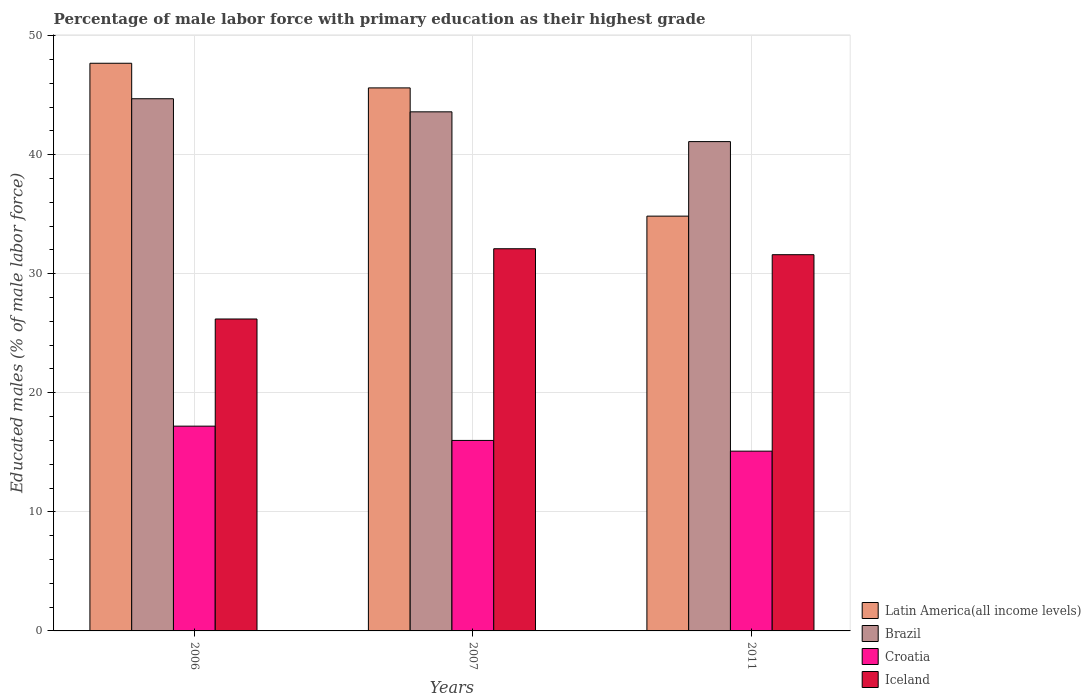How many groups of bars are there?
Keep it short and to the point. 3. Are the number of bars on each tick of the X-axis equal?
Your response must be concise. Yes. How many bars are there on the 3rd tick from the left?
Offer a terse response. 4. What is the percentage of male labor force with primary education in Croatia in 2006?
Provide a short and direct response. 17.2. Across all years, what is the maximum percentage of male labor force with primary education in Iceland?
Your answer should be compact. 32.1. Across all years, what is the minimum percentage of male labor force with primary education in Iceland?
Your answer should be compact. 26.2. In which year was the percentage of male labor force with primary education in Croatia minimum?
Ensure brevity in your answer.  2011. What is the total percentage of male labor force with primary education in Latin America(all income levels) in the graph?
Provide a succinct answer. 128.13. What is the difference between the percentage of male labor force with primary education in Croatia in 2006 and that in 2011?
Give a very brief answer. 2.1. What is the difference between the percentage of male labor force with primary education in Iceland in 2007 and the percentage of male labor force with primary education in Croatia in 2006?
Your response must be concise. 14.9. What is the average percentage of male labor force with primary education in Brazil per year?
Offer a very short reply. 43.13. In the year 2006, what is the difference between the percentage of male labor force with primary education in Iceland and percentage of male labor force with primary education in Brazil?
Keep it short and to the point. -18.5. In how many years, is the percentage of male labor force with primary education in Brazil greater than 38 %?
Your answer should be compact. 3. What is the ratio of the percentage of male labor force with primary education in Brazil in 2006 to that in 2011?
Provide a short and direct response. 1.09. Is the percentage of male labor force with primary education in Brazil in 2006 less than that in 2007?
Keep it short and to the point. No. What is the difference between the highest and the second highest percentage of male labor force with primary education in Latin America(all income levels)?
Ensure brevity in your answer.  2.07. What is the difference between the highest and the lowest percentage of male labor force with primary education in Brazil?
Offer a very short reply. 3.6. In how many years, is the percentage of male labor force with primary education in Iceland greater than the average percentage of male labor force with primary education in Iceland taken over all years?
Offer a terse response. 2. Is it the case that in every year, the sum of the percentage of male labor force with primary education in Brazil and percentage of male labor force with primary education in Iceland is greater than the sum of percentage of male labor force with primary education in Croatia and percentage of male labor force with primary education in Latin America(all income levels)?
Provide a succinct answer. No. What does the 4th bar from the right in 2011 represents?
Give a very brief answer. Latin America(all income levels). Is it the case that in every year, the sum of the percentage of male labor force with primary education in Latin America(all income levels) and percentage of male labor force with primary education in Croatia is greater than the percentage of male labor force with primary education in Brazil?
Your response must be concise. Yes. How many bars are there?
Make the answer very short. 12. What is the difference between two consecutive major ticks on the Y-axis?
Your response must be concise. 10. Are the values on the major ticks of Y-axis written in scientific E-notation?
Make the answer very short. No. Does the graph contain grids?
Your answer should be very brief. Yes. How many legend labels are there?
Your answer should be very brief. 4. What is the title of the graph?
Your answer should be compact. Percentage of male labor force with primary education as their highest grade. Does "Poland" appear as one of the legend labels in the graph?
Your answer should be compact. No. What is the label or title of the Y-axis?
Give a very brief answer. Educated males (% of male labor force). What is the Educated males (% of male labor force) of Latin America(all income levels) in 2006?
Make the answer very short. 47.68. What is the Educated males (% of male labor force) of Brazil in 2006?
Provide a succinct answer. 44.7. What is the Educated males (% of male labor force) of Croatia in 2006?
Keep it short and to the point. 17.2. What is the Educated males (% of male labor force) in Iceland in 2006?
Your answer should be very brief. 26.2. What is the Educated males (% of male labor force) of Latin America(all income levels) in 2007?
Your answer should be very brief. 45.61. What is the Educated males (% of male labor force) of Brazil in 2007?
Offer a very short reply. 43.6. What is the Educated males (% of male labor force) of Iceland in 2007?
Keep it short and to the point. 32.1. What is the Educated males (% of male labor force) in Latin America(all income levels) in 2011?
Ensure brevity in your answer.  34.84. What is the Educated males (% of male labor force) of Brazil in 2011?
Your response must be concise. 41.1. What is the Educated males (% of male labor force) of Croatia in 2011?
Provide a short and direct response. 15.1. What is the Educated males (% of male labor force) in Iceland in 2011?
Your response must be concise. 31.6. Across all years, what is the maximum Educated males (% of male labor force) of Latin America(all income levels)?
Provide a succinct answer. 47.68. Across all years, what is the maximum Educated males (% of male labor force) of Brazil?
Ensure brevity in your answer.  44.7. Across all years, what is the maximum Educated males (% of male labor force) in Croatia?
Your answer should be compact. 17.2. Across all years, what is the maximum Educated males (% of male labor force) of Iceland?
Give a very brief answer. 32.1. Across all years, what is the minimum Educated males (% of male labor force) of Latin America(all income levels)?
Provide a short and direct response. 34.84. Across all years, what is the minimum Educated males (% of male labor force) of Brazil?
Your answer should be very brief. 41.1. Across all years, what is the minimum Educated males (% of male labor force) in Croatia?
Provide a succinct answer. 15.1. Across all years, what is the minimum Educated males (% of male labor force) of Iceland?
Ensure brevity in your answer.  26.2. What is the total Educated males (% of male labor force) of Latin America(all income levels) in the graph?
Ensure brevity in your answer.  128.13. What is the total Educated males (% of male labor force) in Brazil in the graph?
Provide a short and direct response. 129.4. What is the total Educated males (% of male labor force) in Croatia in the graph?
Offer a very short reply. 48.3. What is the total Educated males (% of male labor force) in Iceland in the graph?
Provide a succinct answer. 89.9. What is the difference between the Educated males (% of male labor force) in Latin America(all income levels) in 2006 and that in 2007?
Give a very brief answer. 2.07. What is the difference between the Educated males (% of male labor force) in Brazil in 2006 and that in 2007?
Offer a terse response. 1.1. What is the difference between the Educated males (% of male labor force) in Croatia in 2006 and that in 2007?
Make the answer very short. 1.2. What is the difference between the Educated males (% of male labor force) of Iceland in 2006 and that in 2007?
Give a very brief answer. -5.9. What is the difference between the Educated males (% of male labor force) in Latin America(all income levels) in 2006 and that in 2011?
Your response must be concise. 12.84. What is the difference between the Educated males (% of male labor force) in Latin America(all income levels) in 2007 and that in 2011?
Provide a short and direct response. 10.77. What is the difference between the Educated males (% of male labor force) of Latin America(all income levels) in 2006 and the Educated males (% of male labor force) of Brazil in 2007?
Offer a very short reply. 4.08. What is the difference between the Educated males (% of male labor force) of Latin America(all income levels) in 2006 and the Educated males (% of male labor force) of Croatia in 2007?
Make the answer very short. 31.68. What is the difference between the Educated males (% of male labor force) in Latin America(all income levels) in 2006 and the Educated males (% of male labor force) in Iceland in 2007?
Your answer should be very brief. 15.58. What is the difference between the Educated males (% of male labor force) in Brazil in 2006 and the Educated males (% of male labor force) in Croatia in 2007?
Make the answer very short. 28.7. What is the difference between the Educated males (% of male labor force) in Croatia in 2006 and the Educated males (% of male labor force) in Iceland in 2007?
Your answer should be compact. -14.9. What is the difference between the Educated males (% of male labor force) of Latin America(all income levels) in 2006 and the Educated males (% of male labor force) of Brazil in 2011?
Your answer should be very brief. 6.58. What is the difference between the Educated males (% of male labor force) of Latin America(all income levels) in 2006 and the Educated males (% of male labor force) of Croatia in 2011?
Ensure brevity in your answer.  32.58. What is the difference between the Educated males (% of male labor force) of Latin America(all income levels) in 2006 and the Educated males (% of male labor force) of Iceland in 2011?
Your answer should be very brief. 16.08. What is the difference between the Educated males (% of male labor force) in Brazil in 2006 and the Educated males (% of male labor force) in Croatia in 2011?
Make the answer very short. 29.6. What is the difference between the Educated males (% of male labor force) of Brazil in 2006 and the Educated males (% of male labor force) of Iceland in 2011?
Provide a succinct answer. 13.1. What is the difference between the Educated males (% of male labor force) of Croatia in 2006 and the Educated males (% of male labor force) of Iceland in 2011?
Ensure brevity in your answer.  -14.4. What is the difference between the Educated males (% of male labor force) in Latin America(all income levels) in 2007 and the Educated males (% of male labor force) in Brazil in 2011?
Keep it short and to the point. 4.51. What is the difference between the Educated males (% of male labor force) of Latin America(all income levels) in 2007 and the Educated males (% of male labor force) of Croatia in 2011?
Make the answer very short. 30.51. What is the difference between the Educated males (% of male labor force) of Latin America(all income levels) in 2007 and the Educated males (% of male labor force) of Iceland in 2011?
Offer a terse response. 14.01. What is the difference between the Educated males (% of male labor force) of Brazil in 2007 and the Educated males (% of male labor force) of Croatia in 2011?
Provide a succinct answer. 28.5. What is the difference between the Educated males (% of male labor force) in Brazil in 2007 and the Educated males (% of male labor force) in Iceland in 2011?
Keep it short and to the point. 12. What is the difference between the Educated males (% of male labor force) of Croatia in 2007 and the Educated males (% of male labor force) of Iceland in 2011?
Provide a succinct answer. -15.6. What is the average Educated males (% of male labor force) in Latin America(all income levels) per year?
Your response must be concise. 42.71. What is the average Educated males (% of male labor force) of Brazil per year?
Your answer should be compact. 43.13. What is the average Educated males (% of male labor force) in Iceland per year?
Offer a terse response. 29.97. In the year 2006, what is the difference between the Educated males (% of male labor force) in Latin America(all income levels) and Educated males (% of male labor force) in Brazil?
Your answer should be compact. 2.98. In the year 2006, what is the difference between the Educated males (% of male labor force) in Latin America(all income levels) and Educated males (% of male labor force) in Croatia?
Your answer should be very brief. 30.48. In the year 2006, what is the difference between the Educated males (% of male labor force) in Latin America(all income levels) and Educated males (% of male labor force) in Iceland?
Make the answer very short. 21.48. In the year 2006, what is the difference between the Educated males (% of male labor force) in Brazil and Educated males (% of male labor force) in Croatia?
Keep it short and to the point. 27.5. In the year 2006, what is the difference between the Educated males (% of male labor force) in Brazil and Educated males (% of male labor force) in Iceland?
Keep it short and to the point. 18.5. In the year 2006, what is the difference between the Educated males (% of male labor force) in Croatia and Educated males (% of male labor force) in Iceland?
Make the answer very short. -9. In the year 2007, what is the difference between the Educated males (% of male labor force) of Latin America(all income levels) and Educated males (% of male labor force) of Brazil?
Keep it short and to the point. 2.01. In the year 2007, what is the difference between the Educated males (% of male labor force) in Latin America(all income levels) and Educated males (% of male labor force) in Croatia?
Keep it short and to the point. 29.61. In the year 2007, what is the difference between the Educated males (% of male labor force) in Latin America(all income levels) and Educated males (% of male labor force) in Iceland?
Provide a short and direct response. 13.51. In the year 2007, what is the difference between the Educated males (% of male labor force) of Brazil and Educated males (% of male labor force) of Croatia?
Your response must be concise. 27.6. In the year 2007, what is the difference between the Educated males (% of male labor force) in Croatia and Educated males (% of male labor force) in Iceland?
Your answer should be compact. -16.1. In the year 2011, what is the difference between the Educated males (% of male labor force) of Latin America(all income levels) and Educated males (% of male labor force) of Brazil?
Offer a terse response. -6.26. In the year 2011, what is the difference between the Educated males (% of male labor force) in Latin America(all income levels) and Educated males (% of male labor force) in Croatia?
Your response must be concise. 19.74. In the year 2011, what is the difference between the Educated males (% of male labor force) in Latin America(all income levels) and Educated males (% of male labor force) in Iceland?
Offer a very short reply. 3.24. In the year 2011, what is the difference between the Educated males (% of male labor force) in Croatia and Educated males (% of male labor force) in Iceland?
Provide a succinct answer. -16.5. What is the ratio of the Educated males (% of male labor force) of Latin America(all income levels) in 2006 to that in 2007?
Give a very brief answer. 1.05. What is the ratio of the Educated males (% of male labor force) in Brazil in 2006 to that in 2007?
Offer a very short reply. 1.03. What is the ratio of the Educated males (% of male labor force) of Croatia in 2006 to that in 2007?
Keep it short and to the point. 1.07. What is the ratio of the Educated males (% of male labor force) of Iceland in 2006 to that in 2007?
Your answer should be very brief. 0.82. What is the ratio of the Educated males (% of male labor force) of Latin America(all income levels) in 2006 to that in 2011?
Your answer should be very brief. 1.37. What is the ratio of the Educated males (% of male labor force) of Brazil in 2006 to that in 2011?
Offer a very short reply. 1.09. What is the ratio of the Educated males (% of male labor force) of Croatia in 2006 to that in 2011?
Keep it short and to the point. 1.14. What is the ratio of the Educated males (% of male labor force) of Iceland in 2006 to that in 2011?
Provide a short and direct response. 0.83. What is the ratio of the Educated males (% of male labor force) of Latin America(all income levels) in 2007 to that in 2011?
Your answer should be compact. 1.31. What is the ratio of the Educated males (% of male labor force) of Brazil in 2007 to that in 2011?
Your answer should be compact. 1.06. What is the ratio of the Educated males (% of male labor force) of Croatia in 2007 to that in 2011?
Offer a terse response. 1.06. What is the ratio of the Educated males (% of male labor force) in Iceland in 2007 to that in 2011?
Offer a very short reply. 1.02. What is the difference between the highest and the second highest Educated males (% of male labor force) in Latin America(all income levels)?
Your answer should be compact. 2.07. What is the difference between the highest and the second highest Educated males (% of male labor force) of Croatia?
Keep it short and to the point. 1.2. What is the difference between the highest and the lowest Educated males (% of male labor force) in Latin America(all income levels)?
Make the answer very short. 12.84. What is the difference between the highest and the lowest Educated males (% of male labor force) in Croatia?
Your answer should be very brief. 2.1. What is the difference between the highest and the lowest Educated males (% of male labor force) in Iceland?
Keep it short and to the point. 5.9. 